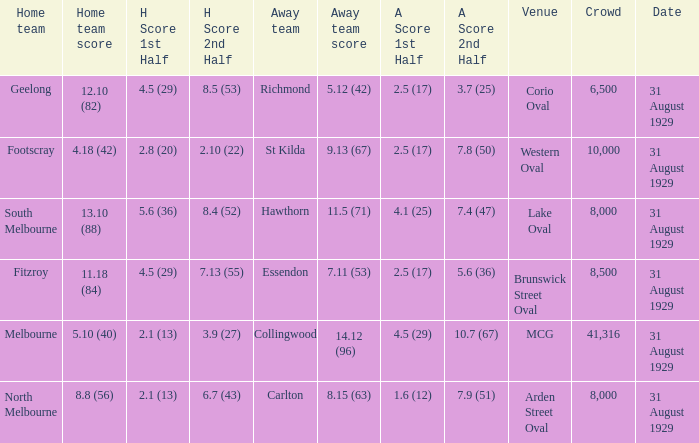What was the away team when the game was at corio oval? Richmond. 